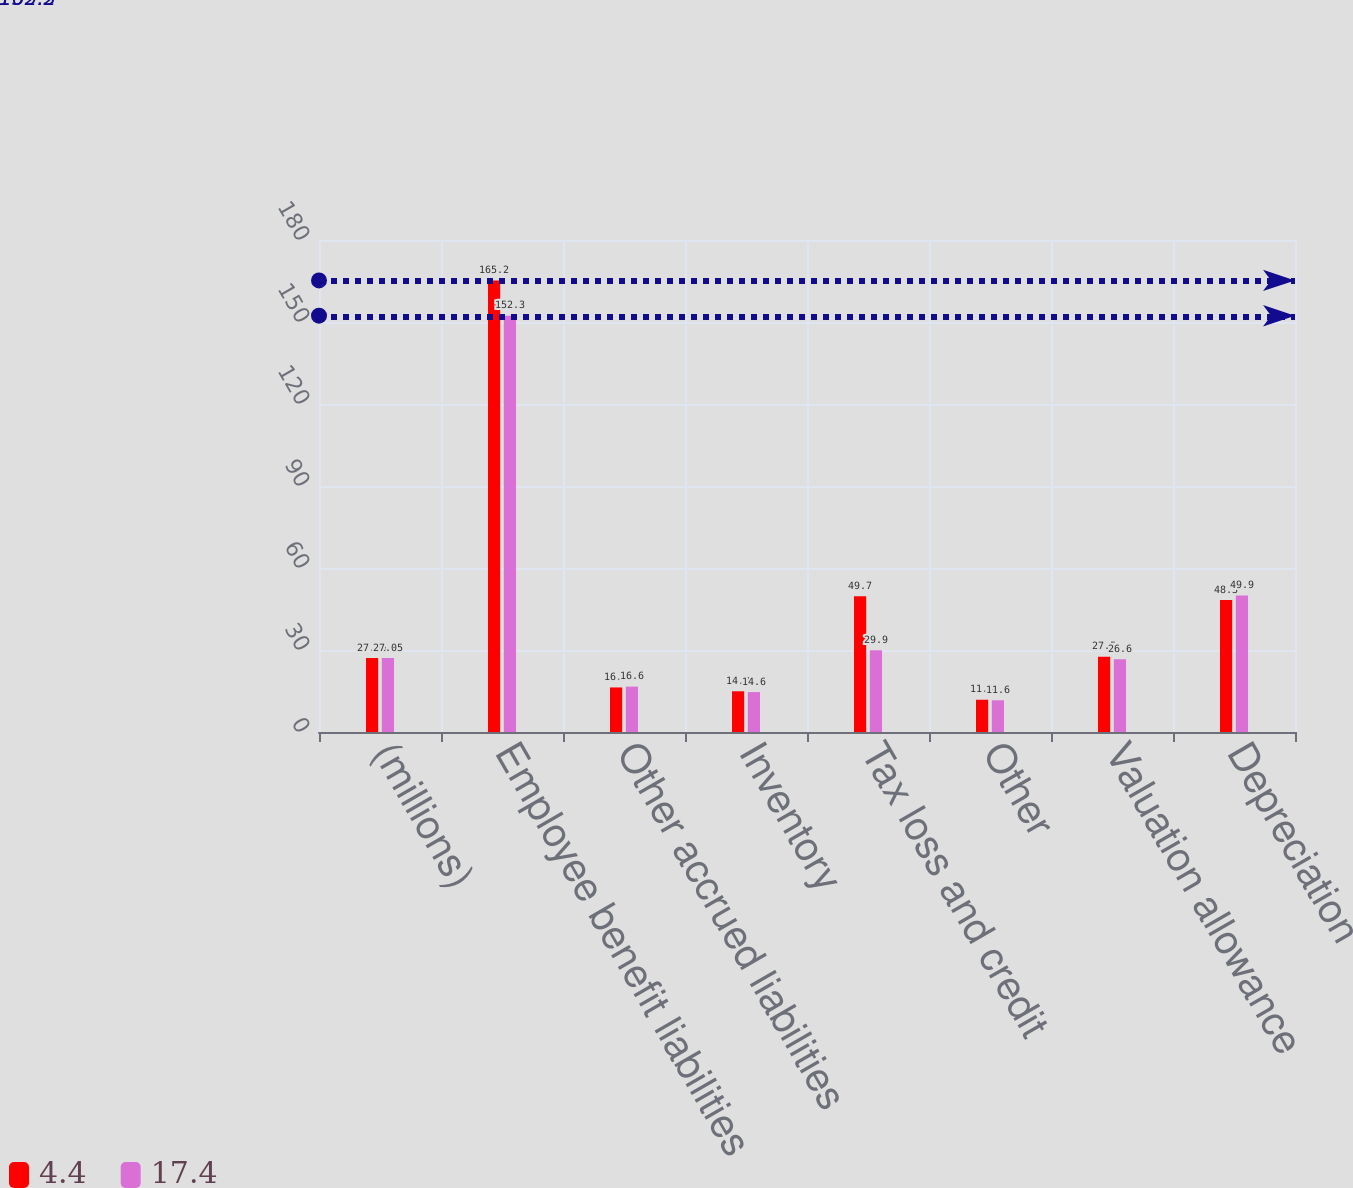Convert chart. <chart><loc_0><loc_0><loc_500><loc_500><stacked_bar_chart><ecel><fcel>(millions)<fcel>Employee benefit liabilities<fcel>Other accrued liabilities<fcel>Inventory<fcel>Tax loss and credit<fcel>Other<fcel>Valuation allowance<fcel>Depreciation<nl><fcel>4.4<fcel>27.05<fcel>165.2<fcel>16.3<fcel>14.9<fcel>49.7<fcel>11.8<fcel>27.5<fcel>48.3<nl><fcel>17.4<fcel>27.05<fcel>152.3<fcel>16.6<fcel>14.6<fcel>29.9<fcel>11.6<fcel>26.6<fcel>49.9<nl></chart> 